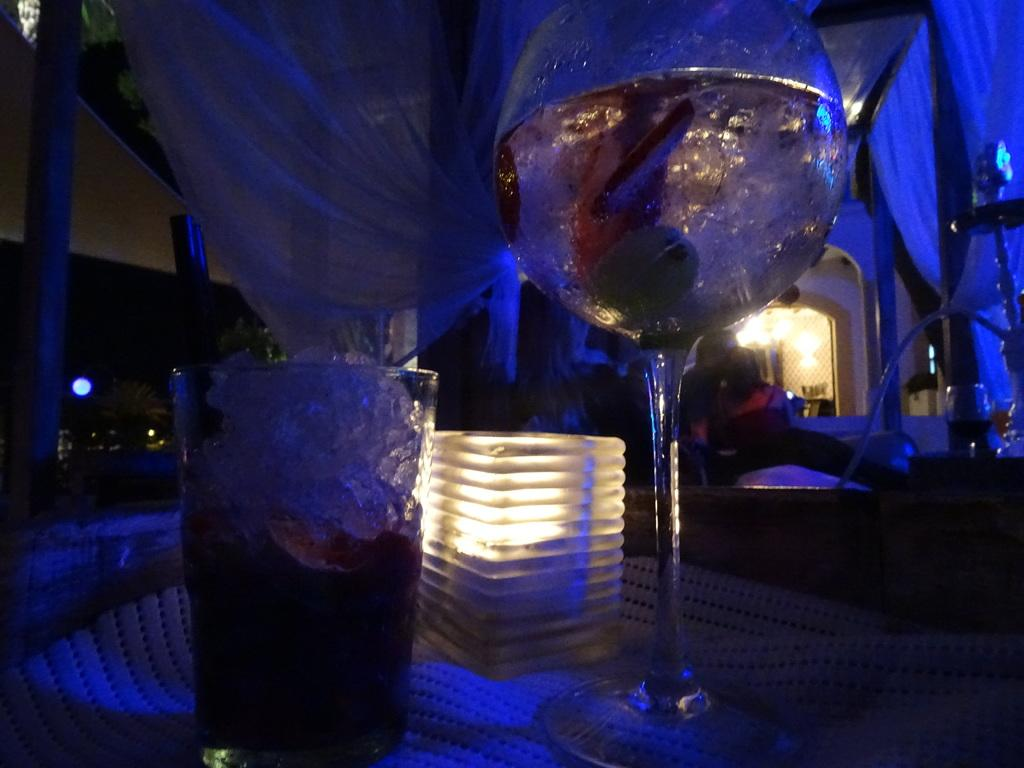What objects are on the table in the image? There are glasses and a light on the table in the image. Can you describe the light on the table? There is a light on the table in the image. What else is visible in the image besides the table and its contents? There are lights visible in the image. What can be seen in the background of the image? There is a cloth in the background of the image. What type of pest can be seen crawling on the cloth in the image? There is no pest visible in the image; it only shows glasses, a light, and lights on a table with a cloth in the background. 